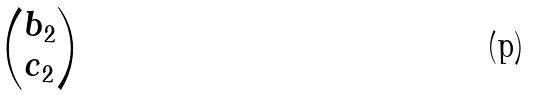<formula> <loc_0><loc_0><loc_500><loc_500>\begin{pmatrix} b _ { 2 } \\ c _ { 2 } \end{pmatrix}</formula> 